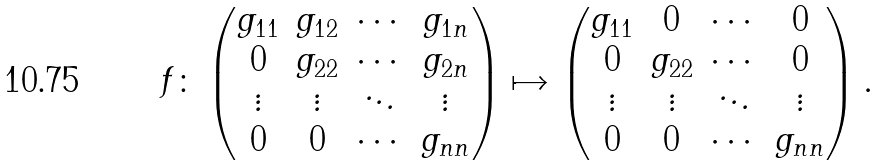Convert formula to latex. <formula><loc_0><loc_0><loc_500><loc_500>f \colon \begin{pmatrix} g _ { 1 1 } & g _ { 1 2 } & \cdots & g _ { 1 n } \\ 0 & g _ { 2 2 } & \cdots & g _ { 2 n } \\ \vdots & \vdots & \ddots & \vdots \\ 0 & 0 & \cdots & g _ { n n } \end{pmatrix} \mapsto \begin{pmatrix} g _ { 1 1 } & 0 & \cdots & 0 \\ 0 & g _ { 2 2 } & \cdots & 0 \\ \vdots & \vdots & \ddots & \vdots \\ 0 & 0 & \cdots & g _ { n n } \end{pmatrix} .</formula> 